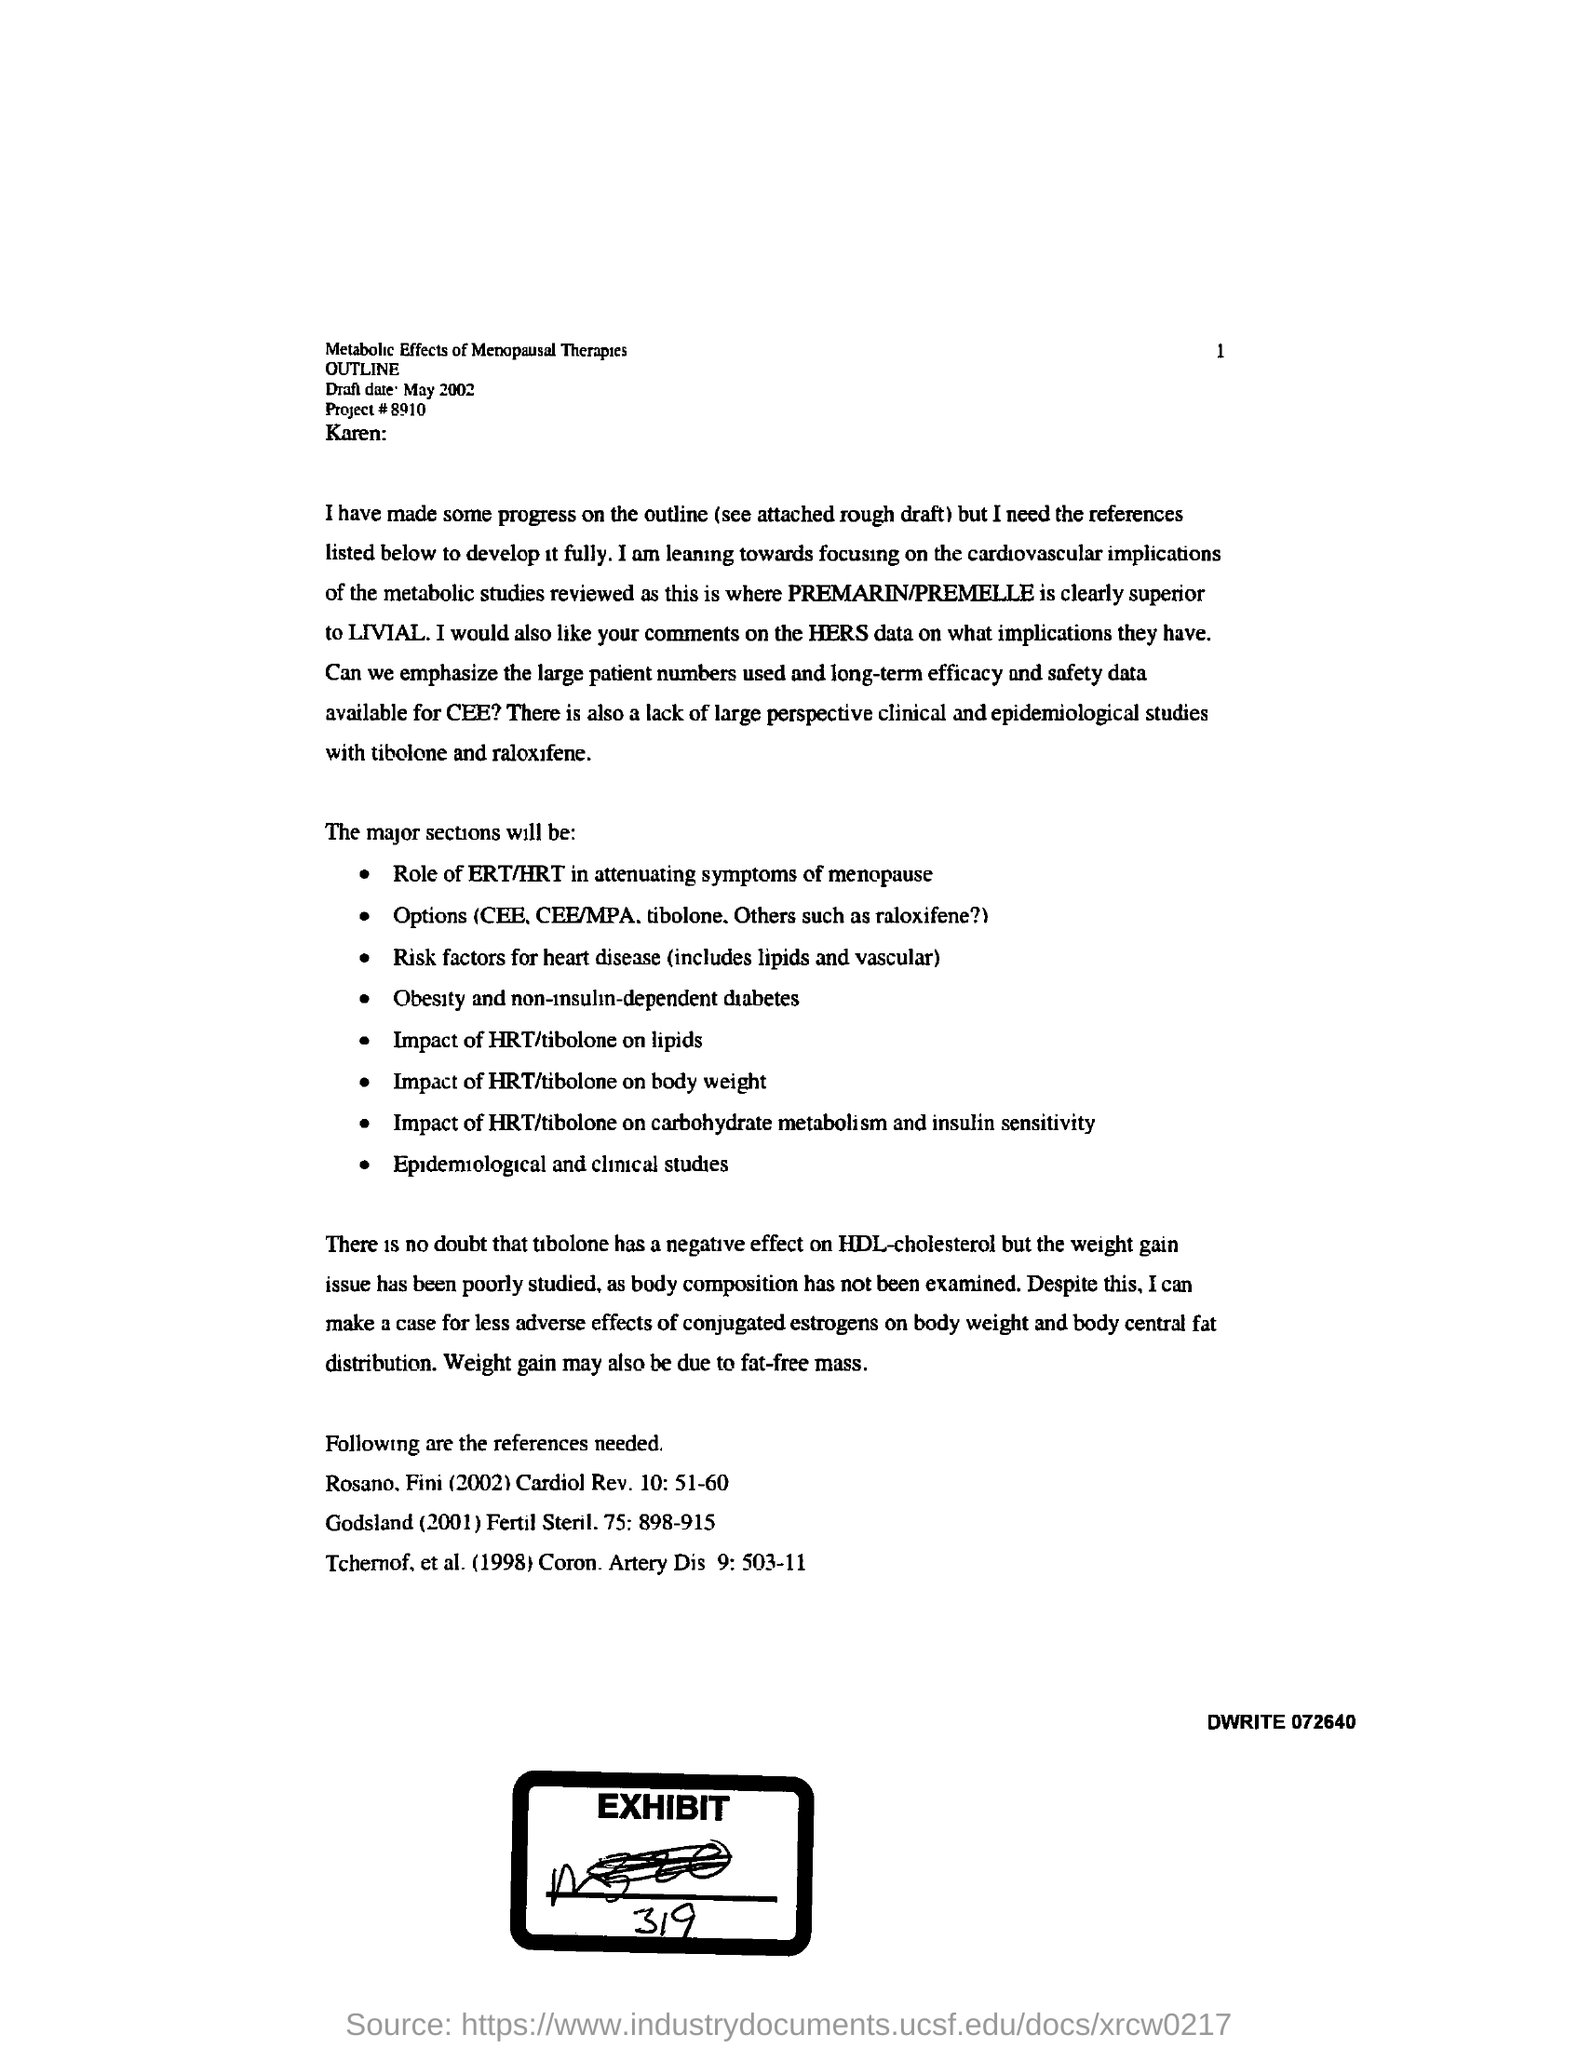Mention a couple of crucial points in this snapshot. The due date for the draft is May 2002. Please provide the project number, the project number is 8910... 